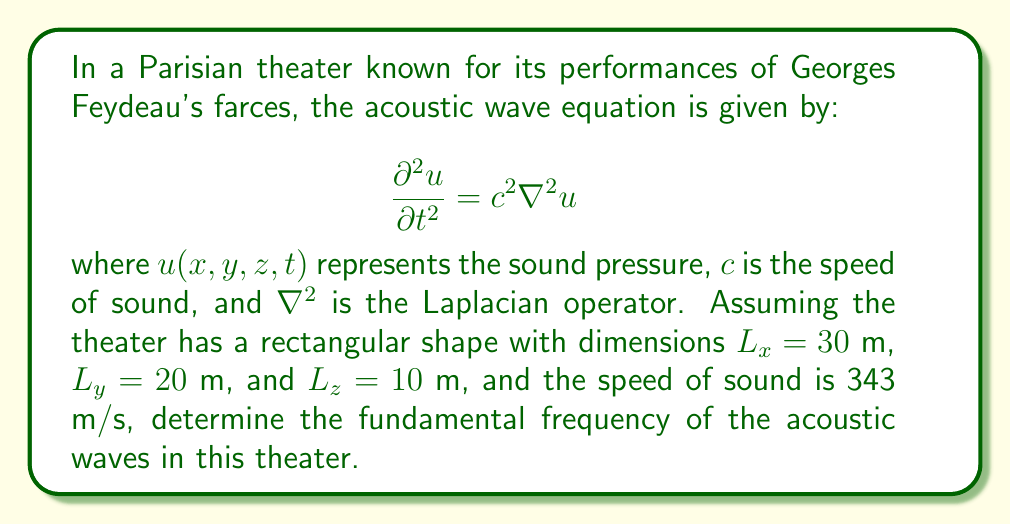Can you solve this math problem? To solve this problem, we need to follow these steps:

1) The general solution for the wave equation in a rectangular room is given by:

   $$u(x,y,z,t) = \sum_{l,m,n} A_{lmn} \cos(\omega_{lmn}t) \cos(\frac{l\pi x}{L_x}) \cos(\frac{m\pi y}{L_y}) \cos(\frac{n\pi z}{L_z})$$

2) The corresponding frequencies are:

   $$f_{lmn} = \frac{c}{2} \sqrt{(\frac{l}{L_x})^2 + (\frac{m}{L_y})^2 + (\frac{n}{L_z})^2}$$

3) The fundamental frequency corresponds to the lowest non-zero frequency, which occurs when $l=1$, $m=0$, and $n=0$. Substituting these values:

   $$f_{100} = \frac{c}{2} \sqrt{(\frac{1}{L_x})^2 + 0 + 0} = \frac{c}{2L_x}$$

4) Now, let's substitute the given values:

   $$f_{100} = \frac{343 \text{ m/s}}{2 \cdot 30 \text{ m}} = 5.72 \text{ Hz}$$

Therefore, the fundamental frequency of the acoustic waves in this Parisian theater is approximately 5.72 Hz.
Answer: 5.72 Hz 